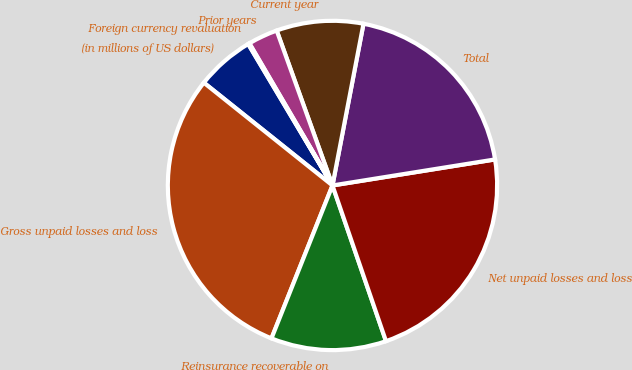Convert chart. <chart><loc_0><loc_0><loc_500><loc_500><pie_chart><fcel>(in millions of US dollars)<fcel>Gross unpaid losses and loss<fcel>Reinsurance recoverable on<fcel>Net unpaid losses and loss<fcel>Total<fcel>Current year<fcel>Prior years<fcel>Foreign currency revaluation<nl><fcel>5.72%<fcel>29.69%<fcel>11.31%<fcel>22.26%<fcel>19.46%<fcel>8.52%<fcel>2.92%<fcel>0.13%<nl></chart> 